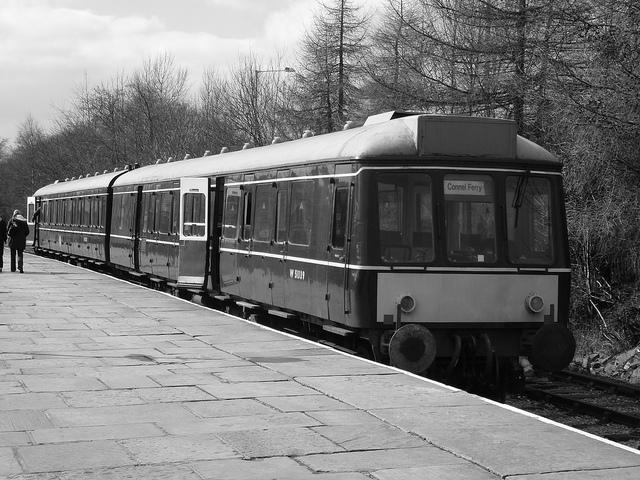What does the sign on the front of the train say?
Give a very brief answer. Can't see. What color are the doors?
Concise answer only. White. Where is this train car at?
Write a very short answer. Station. Is the picture black and white?
Answer briefly. Yes. What type of transportation is this?
Concise answer only. Train. 